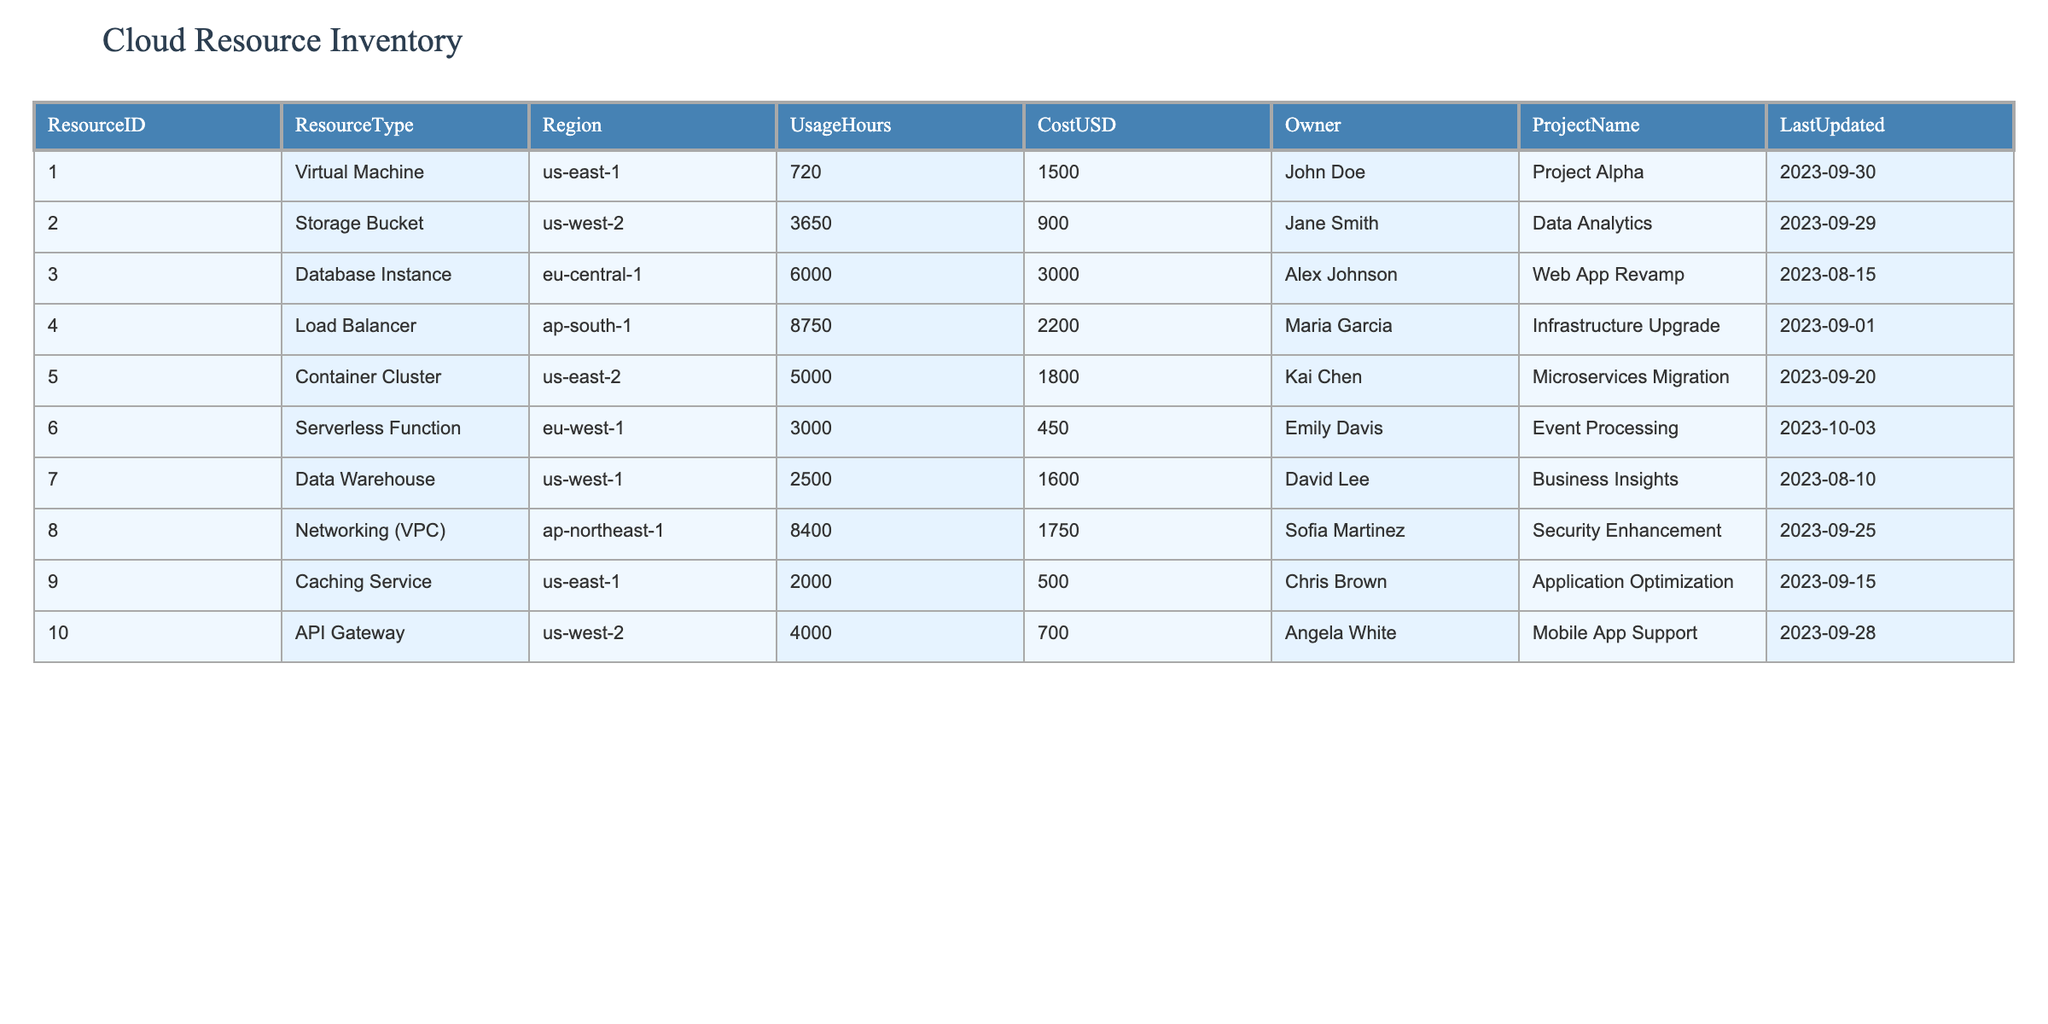What is the total cost of all cloud resources? To find the total cost, we need to sum the costs from all the rows in the CostUSD column. The individual costs are: 1500 + 900 + 3000 + 2200 + 1800 + 450 + 1600 + 1750 + 500 + 700 = 14600.
Answer: 14600 Which region has the highest UsageHours? By reviewing the UsageHours for each region, we see: us-east-1 (720), us-west-2 (3650), eu-central-1 (6000), ap-south-1 (8750), us-east-2 (5000), eu-west-1 (3000), us-west-1 (2500), ap-northeast-1 (8400), and us-east-1 (2000) again. The highest is ap-south-1 with 8750 hours.
Answer: ap-south-1 Is there a resource owner named Jane Smith? We look through the Owner column to see if Jane Smith appears. Upon inspection, Jane Smith is indeed listed as the owner for the Storage Bucket resource.
Answer: Yes How many resources have a UsageHours greater than 4000? We check each resource's UsageHours: 6000 (eu-central-1), 8750 (ap-south-1), 5000 (us-east-2), 4000 (us-west-2). Counting these, we find four resources exceed 4000 UsageHours.
Answer: 4 What is the average cost of resources owned by John Doe? John Doe owns one resource, the Virtual Machine, which costs 1500. The average cost is calculated as the total cost divided by the number of resources owned: 1500/1 = 1500.
Answer: 1500 Is the total UsageHours for the project "Data Analytics" more than 3500? The usage for "Data Analytics," owned by Jane Smith, is 3650. Since 3650 is greater than 3500, the answer is yes.
Answer: Yes What is the cost difference between the most expensive and the least expensive resource? The most expensive resource is the Database Instance at 3000 and the least expensive is the Serverless Function at 450. The difference is calculated as 3000 - 450 = 2550.
Answer: 2550 Which project has the highest total cost? We calculate the total cost for each project: Project Alpha (1500), Data Analytics (900), Web App Revamp (3000), Infrastructure Upgrade (2200), Microservices Migration (1800), Event Processing (450), Business Insights (1600), Security Enhancement (1750), and Mobile App Support (700). The highest total cost is for Web App Revamp at 3000.
Answer: Web App Revamp 